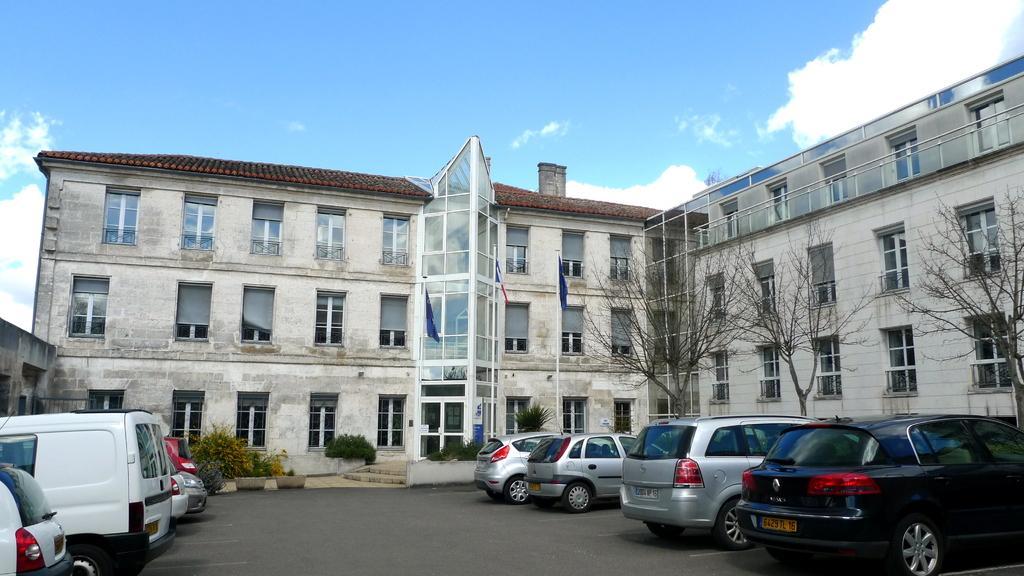Describe this image in one or two sentences. In this image I can see few buildings, windows, flags, dry trees, stairs and few vehicles on the road. The sky is in white and blue color. 